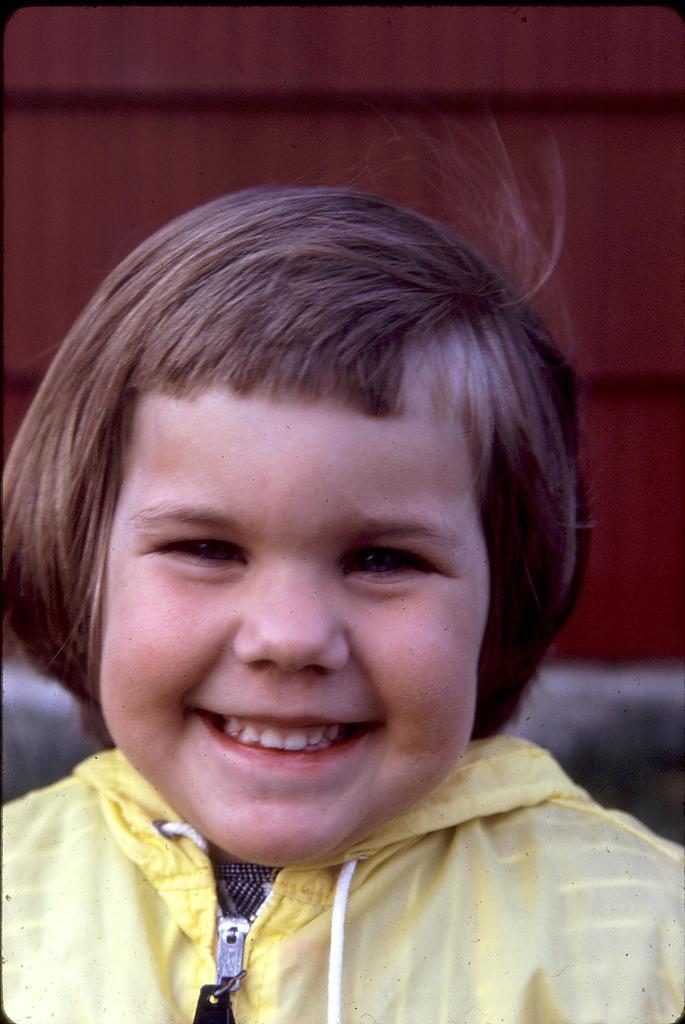Please provide a concise description of this image. In this picture there is a person with yellow jacket is smiling. At the back there is a maroon background. This picture is an edited picture. 